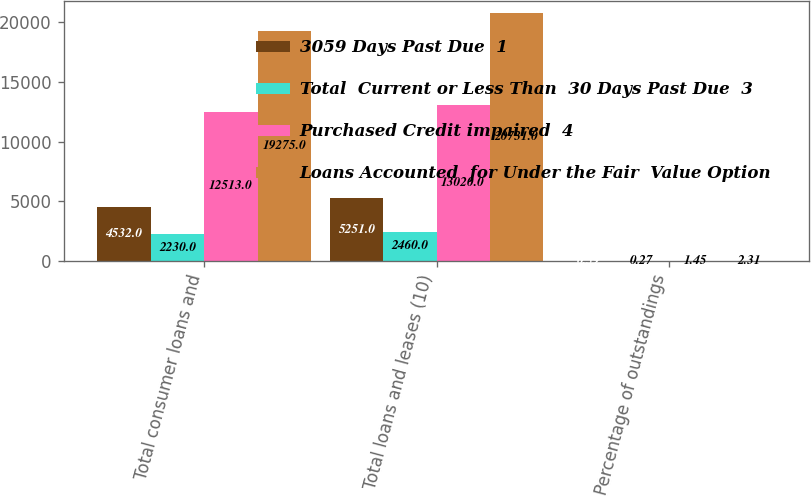<chart> <loc_0><loc_0><loc_500><loc_500><stacked_bar_chart><ecel><fcel>Total consumer loans and<fcel>Total loans and leases (10)<fcel>Percentage of outstandings<nl><fcel>3059 Days Past Due  1<fcel>4532<fcel>5251<fcel>0.59<nl><fcel>Total  Current or Less Than  30 Days Past Due  3<fcel>2230<fcel>2460<fcel>0.27<nl><fcel>Purchased Credit impaired  4<fcel>12513<fcel>13020<fcel>1.45<nl><fcel>Loans Accounted  for Under the Fair  Value Option<fcel>19275<fcel>20731<fcel>2.31<nl></chart> 